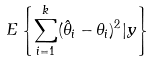Convert formula to latex. <formula><loc_0><loc_0><loc_500><loc_500>E \left \{ \sum _ { i = 1 } ^ { k } ( \hat { \theta } _ { i } - \theta _ { i } ) ^ { 2 } | y \right \}</formula> 